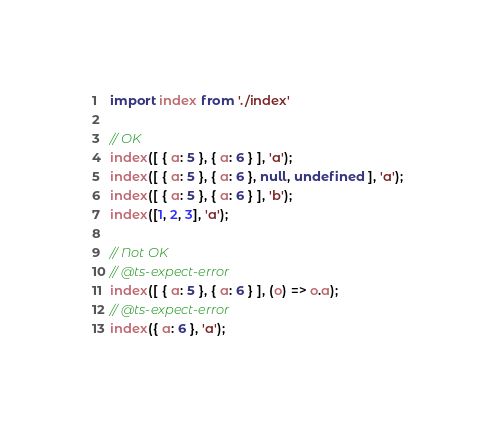<code> <loc_0><loc_0><loc_500><loc_500><_TypeScript_>import index from './index'

// OK
index([ { a: 5 }, { a: 6 } ], 'a');
index([ { a: 5 }, { a: 6 }, null, undefined ], 'a');
index([ { a: 5 }, { a: 6 } ], 'b');
index([1, 2, 3], 'a');

// Not OK
// @ts-expect-error
index([ { a: 5 }, { a: 6 } ], (o) => o.a);
// @ts-expect-error
index({ a: 6 }, 'a');
</code> 